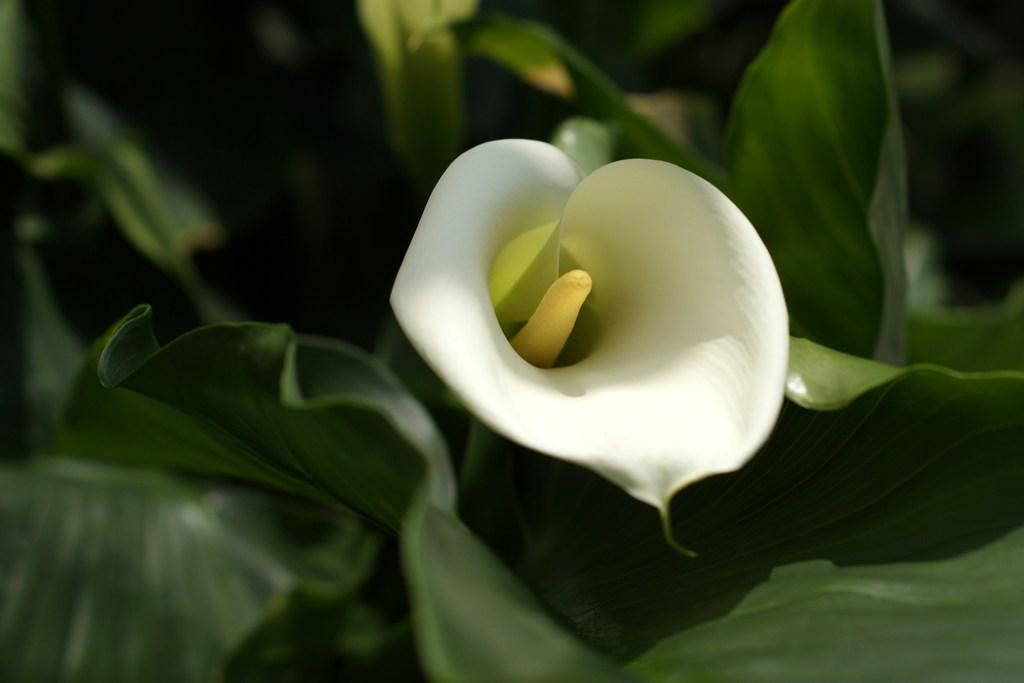What color can be seen in the image? There is a white color in the image. What type of vegetation is present in the image? There are green leaves in the image. Where is the sand located in the image? There is no sand present in the image. What type of food is being prepared in the image? There is no food preparation visible in the image. 